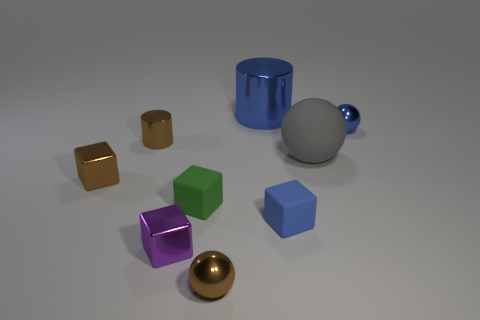Add 1 tiny purple cubes. How many objects exist? 10 Subtract all cylinders. How many objects are left? 7 Subtract 1 blue cubes. How many objects are left? 8 Subtract all big brown metallic cylinders. Subtract all brown cubes. How many objects are left? 8 Add 3 blue matte things. How many blue matte things are left? 4 Add 1 tiny brown things. How many tiny brown things exist? 4 